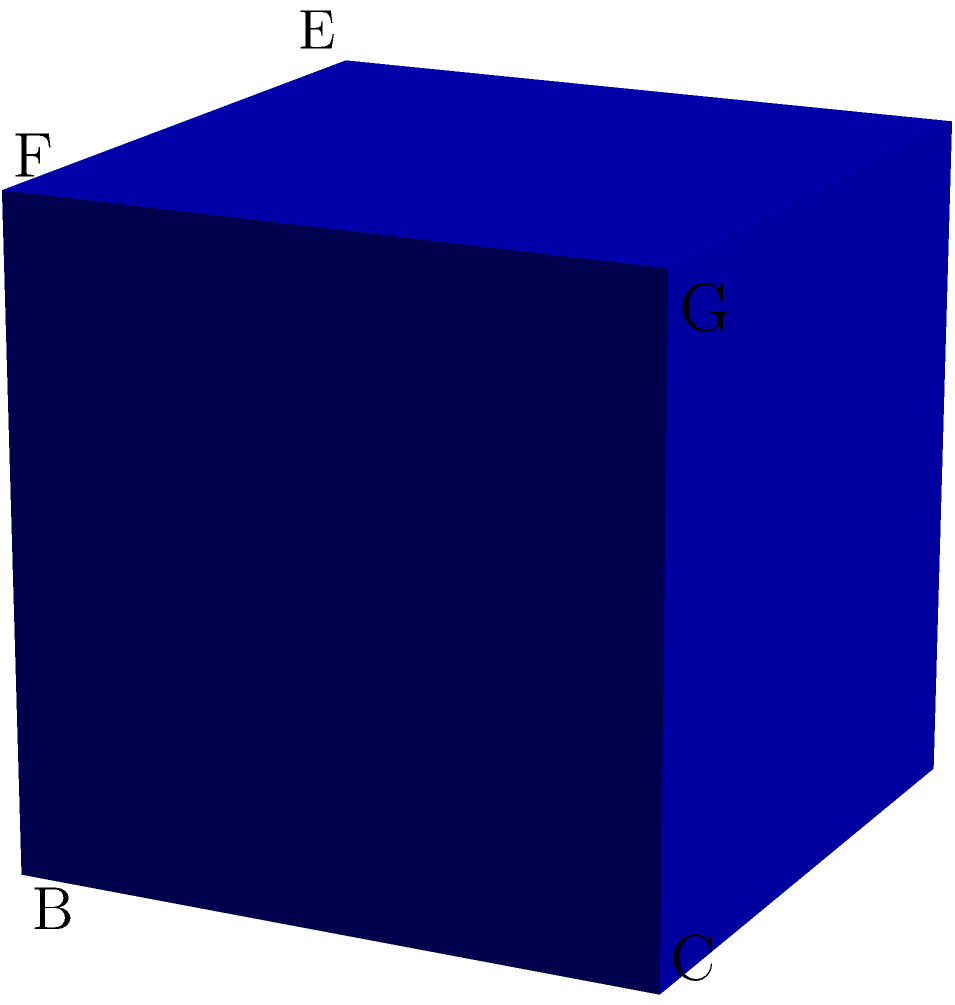Consider the symmetry group of a cube. What is the order of the rotation that maps the cube onto itself by rotating it 120° around the diagonal from vertex A to vertex G? To determine the order of this rotation, we need to follow these steps:

1) First, recall that the order of an element in a group is the smallest positive integer $n$ such that $g^n = e$, where $e$ is the identity element.

2) In this case, we need to find how many times we need to apply this 120° rotation to get back to the original position.

3) Let's track the movement of vertex B:
   - After one 120° rotation: B → F
   - After two 120° rotations: B → F → H
   - After three 120° rotations: B → F → H → B

4) We see that after three rotations, we return to the original position.

5) This means that applying this rotation three times is equivalent to the identity transformation.

6) Therefore, the order of this rotation is 3.

This result is consistent with the fact that rotations by 120° are always of order 3 in three-dimensional space, regardless of the specific object being rotated.
Answer: 3 